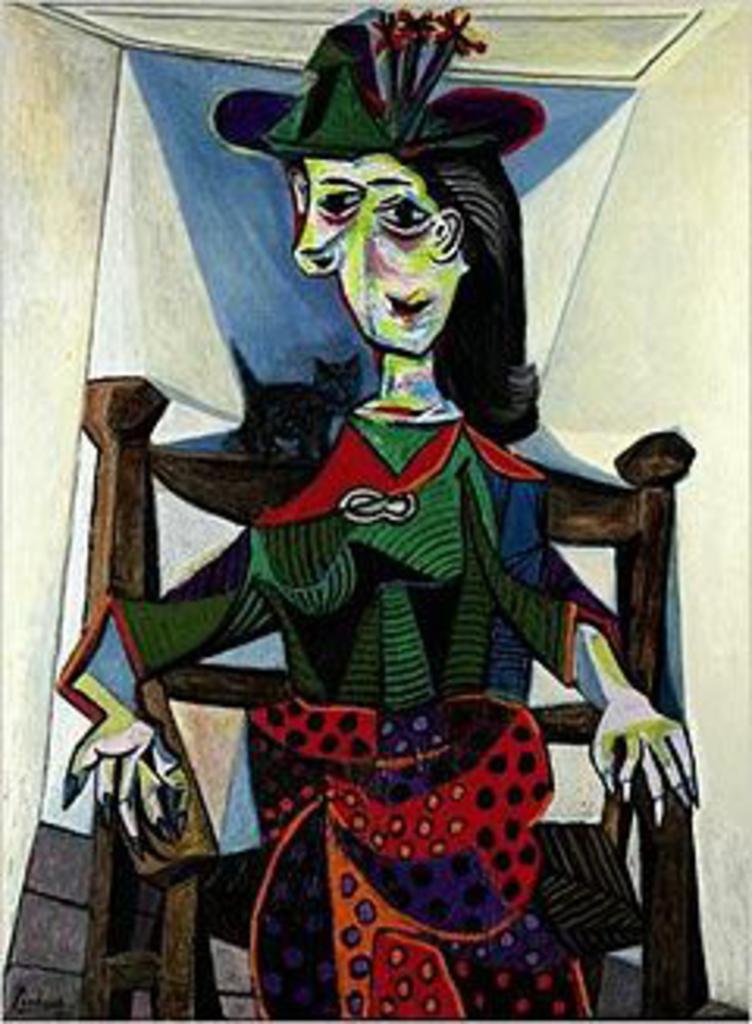In one or two sentences, can you explain what this image depicts? In this picture we can see a painting, in this painting we can see a person is sitting on a chair. 